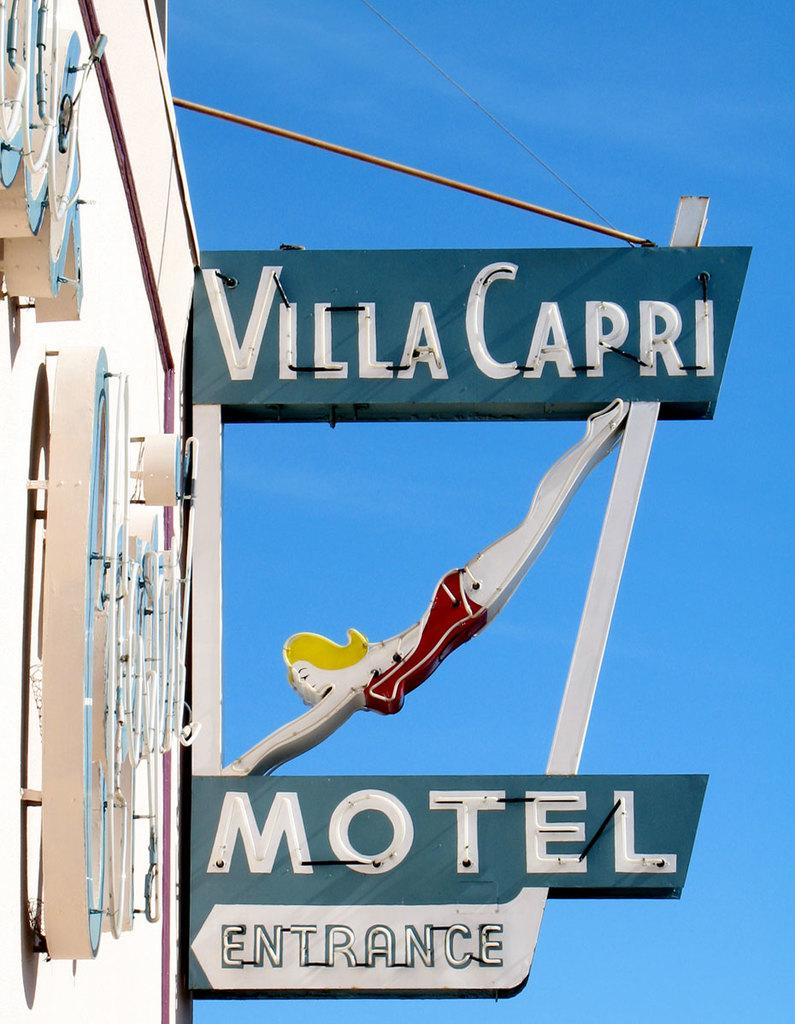Provide a one-sentence caption for the provided image. motel sign that reads villa capri and in blue. 